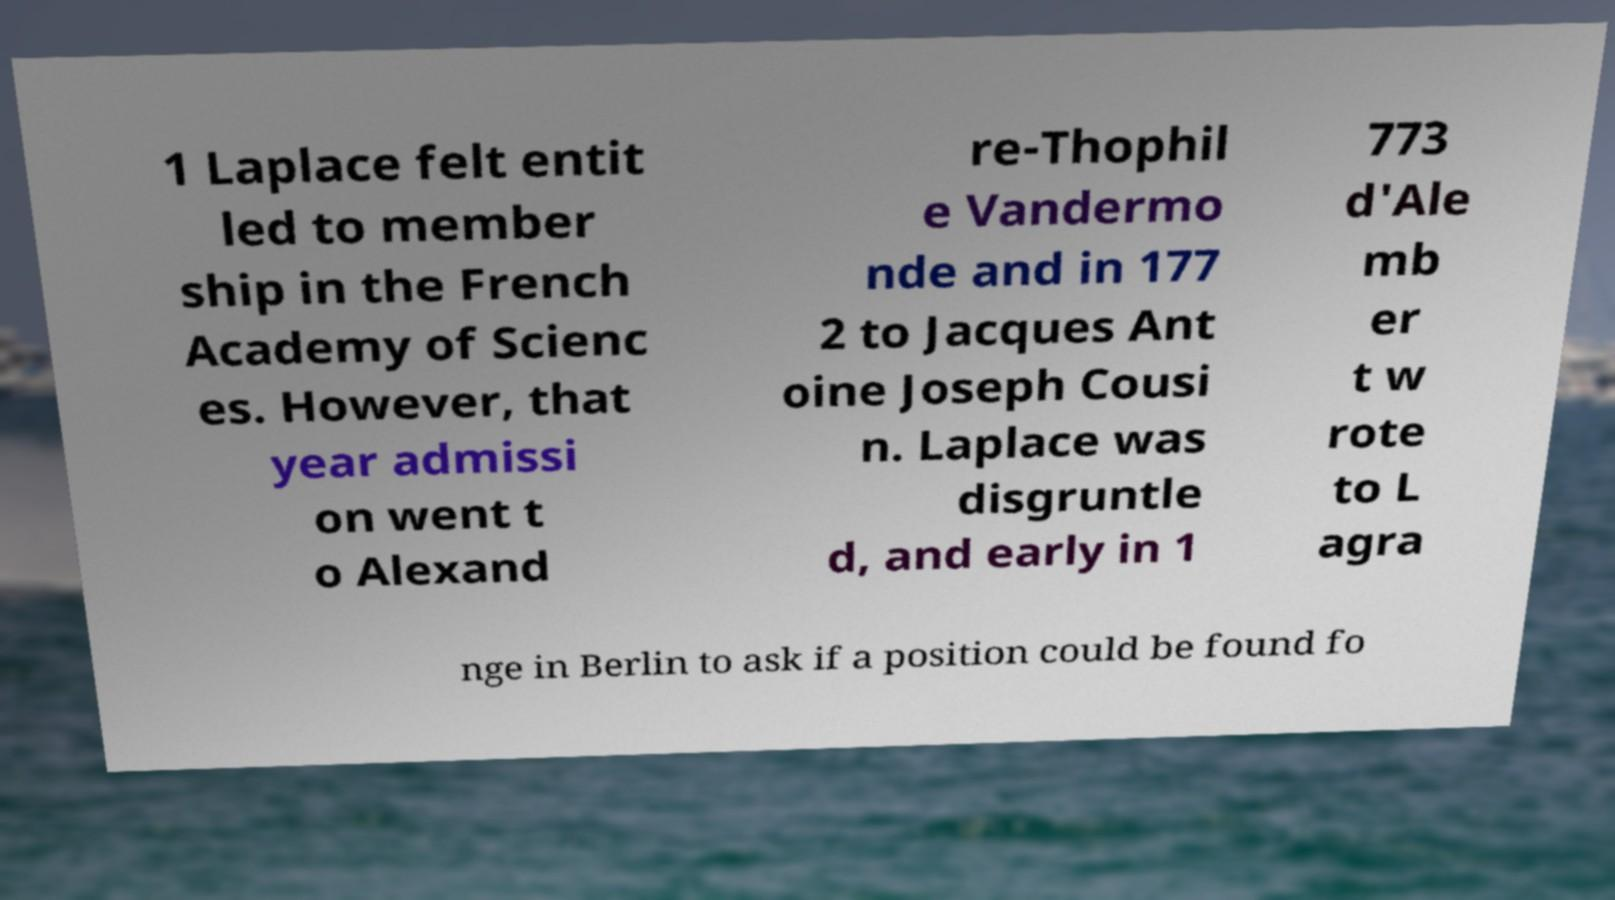Could you extract and type out the text from this image? 1 Laplace felt entit led to member ship in the French Academy of Scienc es. However, that year admissi on went t o Alexand re-Thophil e Vandermo nde and in 177 2 to Jacques Ant oine Joseph Cousi n. Laplace was disgruntle d, and early in 1 773 d'Ale mb er t w rote to L agra nge in Berlin to ask if a position could be found fo 